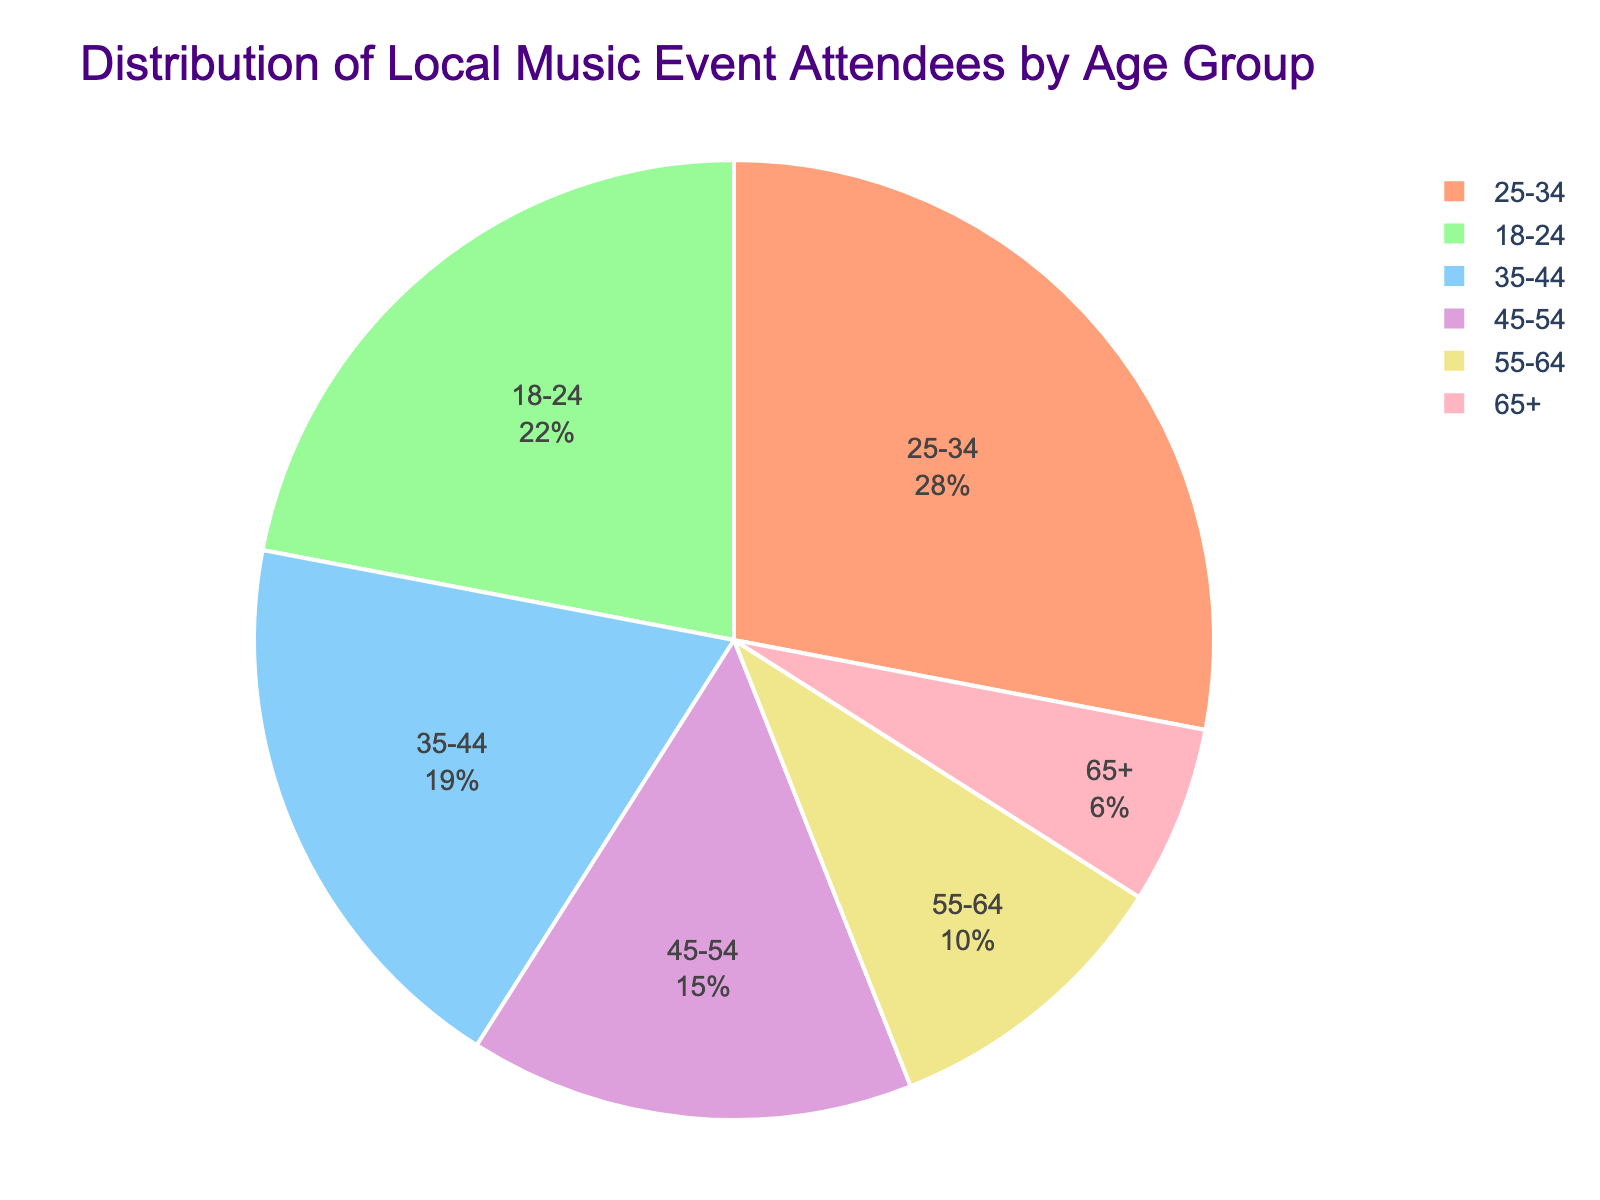What percentage of attendees are aged 25-34? By referring to the figure, we can directly see that the label for the age group 25-34 shows a percentage of 28%.
Answer: 28% Which age group forms the smallest segment of attendees? In the pie chart, the smallest segment is visually the least filled area which corresponds to the age group 65+.
Answer: 65+ What is the combined percentage of attendees who are aged 45-64? The 45-54 group has 15%, and the 55-64 group has 10%. The combined percentage is 15% + 10% = 25%.
Answer: 25% Which two age groups together represent more than 50% of the attendees? The largest segments are for the age groups 25-34 (28%) and 18-24 (22%). Adding these, 28% + 22% = 50%, which is precisely 50%. Hence, these two groups together represent 50% of the attendees.
Answer: 25-34 and 18-24 Is the number of attendees in the 35-44 age group greater than those in the 55-64 age group? From the figure, the 35-44 age group has 19% of the attendees, whereas the 55-64 age group has 10%. Since 19% is greater than 10%, the number of attendees in the 35-44 age group is indeed greater.
Answer: Yes What percentage of attendees are aged 54 or younger? Adding all age groups from 18-24 up to 45-54: 22% + 28% + 19% + 15% = 84%. Therefore, 84% of attendees are aged 54 or younger.
Answer: 84% What is the difference in percentage between the 18-24 and the 65+ age groups? The 18-24 age group has 22% of attendees and the 65+ age group has 6%. The difference is 22% - 6% = 16%.
Answer: 16% Which age group has the second highest percentage of attendees? From the pie chart, the age group with the highest percentage is 25-34 with 28%. The next largest proportion is 18-24 with 22%. So, the second highest percentage is held by the 18-24 age group.
Answer: 18-24 Is the percentage of attendees aged 18-24 and 25-34 combined greater than the percentage of all other age groups combined? Adding the 18-24 (22%) and 25-34 (28%) results in 22% + 28% = 50%. The percentages of the other age groups combined are 19% + 15% + 10% + 6% = 50%. Both sums are equal, so the combined percentage is not greater.
Answer: No What is the average percentage of attendees for the age groups from 45-54 and 55-64? The percentages for the groups 45-54 and 55-64 are 15% and 10%, respectively. To find the average: (15% + 10%) / 2 = 12.5%.
Answer: 12.5% 